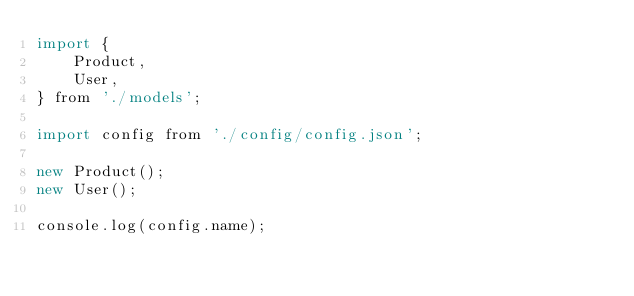Convert code to text. <code><loc_0><loc_0><loc_500><loc_500><_JavaScript_>import {
    Product,
    User,
} from './models';

import config from './config/config.json';

new Product();
new User();

console.log(config.name);
</code> 